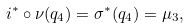Convert formula to latex. <formula><loc_0><loc_0><loc_500><loc_500>i ^ { \ast } \circ \nu ( q _ { 4 } ) = \sigma ^ { \ast } ( q _ { 4 } ) = \mu _ { 3 } ,</formula> 